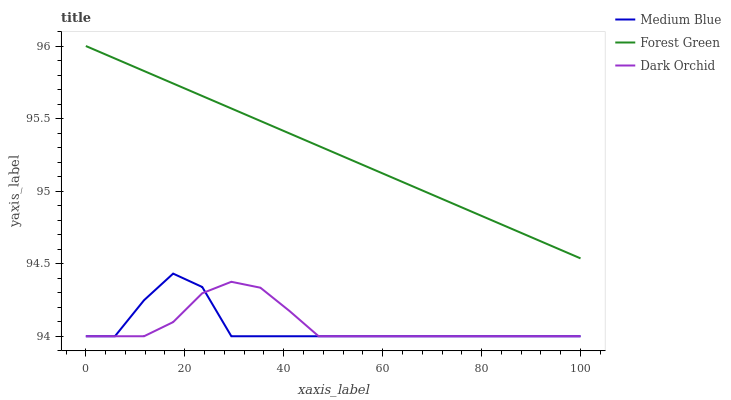Does Medium Blue have the minimum area under the curve?
Answer yes or no. Yes. Does Forest Green have the maximum area under the curve?
Answer yes or no. Yes. Does Dark Orchid have the minimum area under the curve?
Answer yes or no. No. Does Dark Orchid have the maximum area under the curve?
Answer yes or no. No. Is Forest Green the smoothest?
Answer yes or no. Yes. Is Medium Blue the roughest?
Answer yes or no. Yes. Is Dark Orchid the smoothest?
Answer yes or no. No. Is Dark Orchid the roughest?
Answer yes or no. No. Does Forest Green have the highest value?
Answer yes or no. Yes. Does Medium Blue have the highest value?
Answer yes or no. No. Is Medium Blue less than Forest Green?
Answer yes or no. Yes. Is Forest Green greater than Medium Blue?
Answer yes or no. Yes. Does Dark Orchid intersect Medium Blue?
Answer yes or no. Yes. Is Dark Orchid less than Medium Blue?
Answer yes or no. No. Is Dark Orchid greater than Medium Blue?
Answer yes or no. No. Does Medium Blue intersect Forest Green?
Answer yes or no. No. 